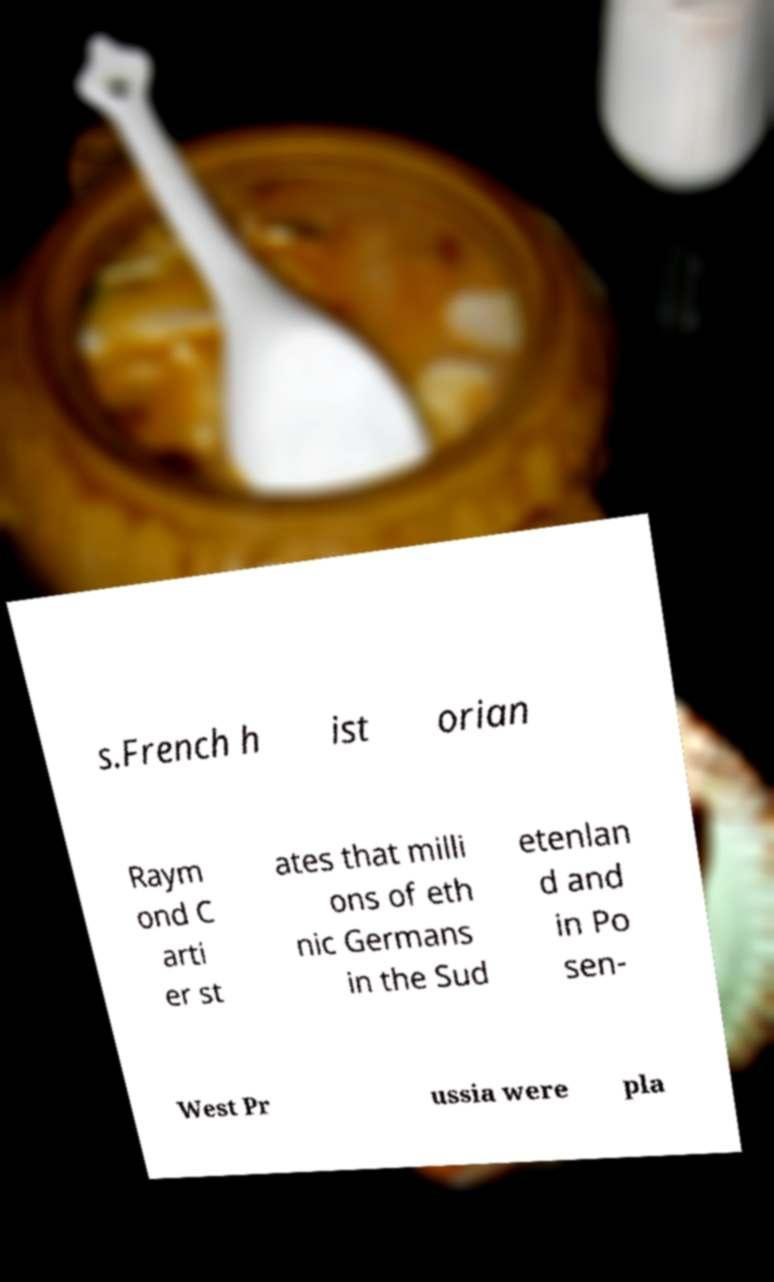There's text embedded in this image that I need extracted. Can you transcribe it verbatim? s.French h ist orian Raym ond C arti er st ates that milli ons of eth nic Germans in the Sud etenlan d and in Po sen- West Pr ussia were pla 